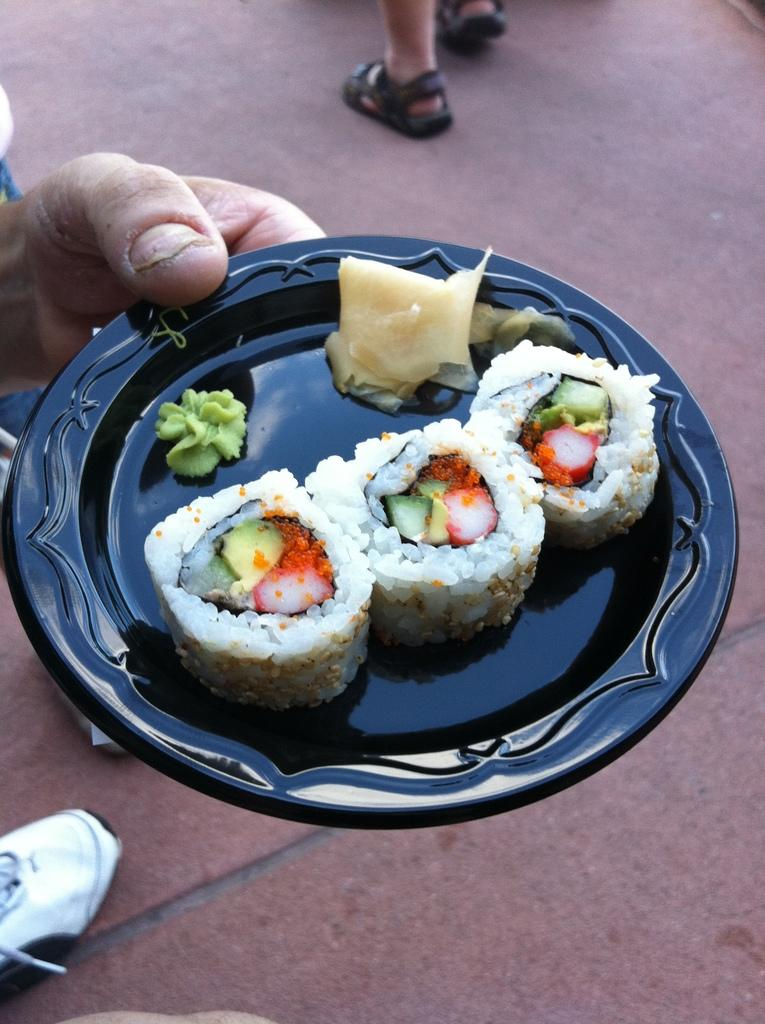What is the person's hand holding in the image? The person's hand is holding a plate in the image. What is on the plate that the person is holding? The plate contains food. What part of the people in the image can be seen? People's legs are visible in the image. What type of power cable can be seen running along the sidewalk in the image? There is no power cable or sidewalk present in the image. 